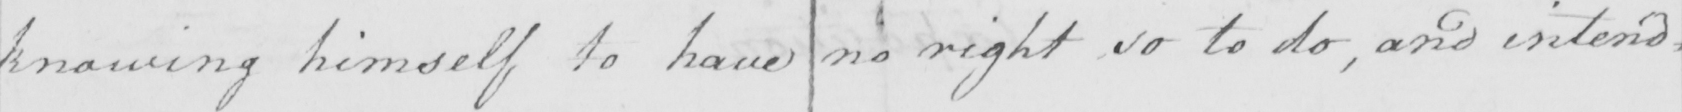Please transcribe the handwritten text in this image. knowing himself to have no right so to do , and intend= 